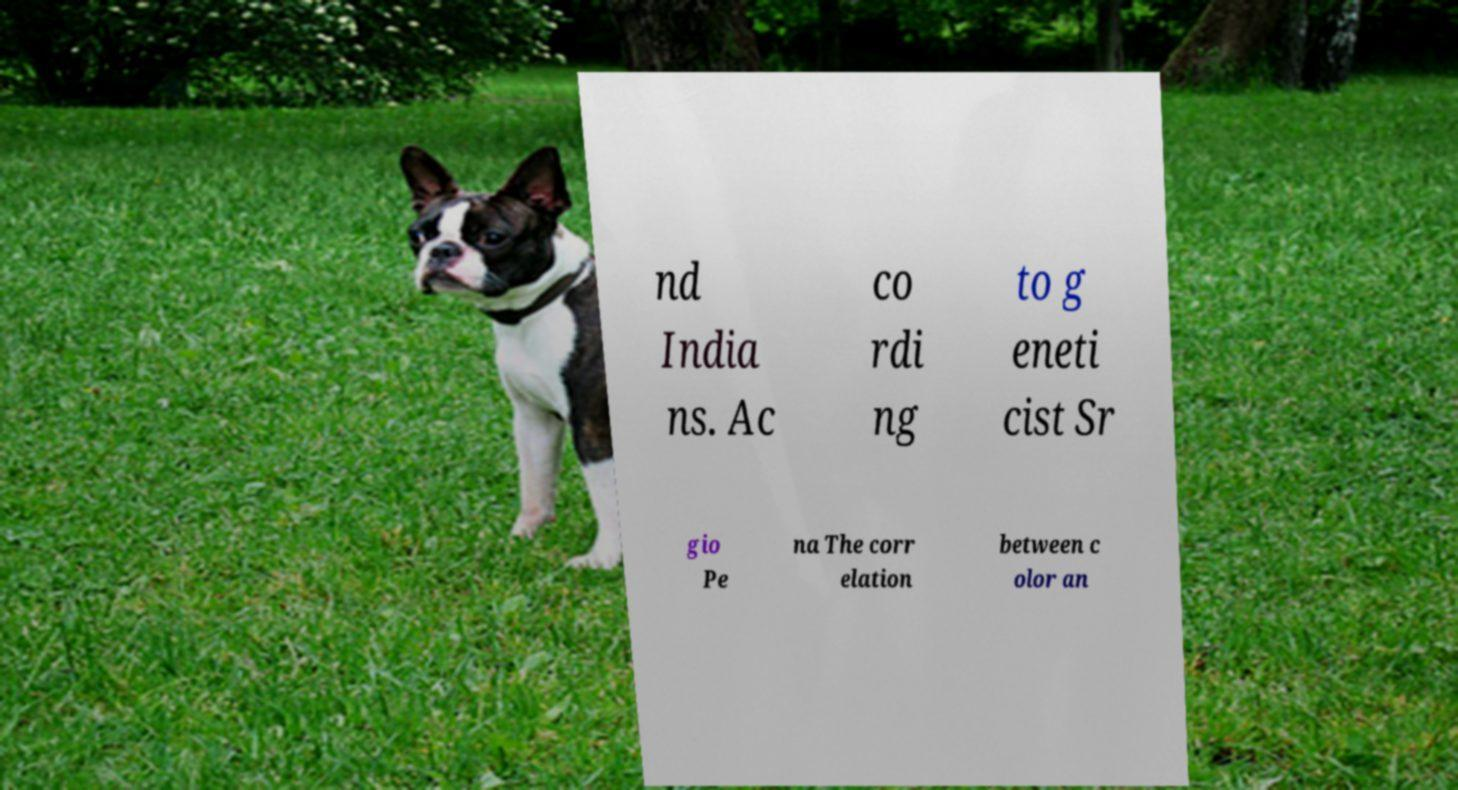Could you extract and type out the text from this image? nd India ns. Ac co rdi ng to g eneti cist Sr gio Pe na The corr elation between c olor an 